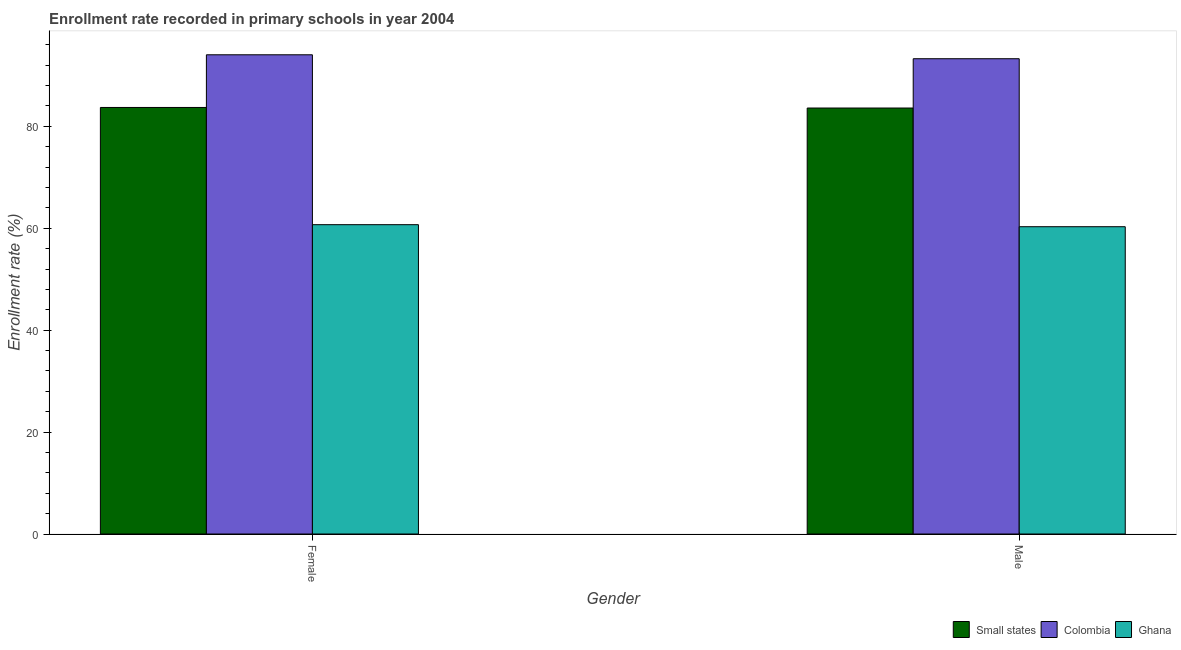How many bars are there on the 2nd tick from the left?
Keep it short and to the point. 3. What is the label of the 1st group of bars from the left?
Your response must be concise. Female. What is the enrollment rate of male students in Ghana?
Provide a short and direct response. 60.31. Across all countries, what is the maximum enrollment rate of female students?
Give a very brief answer. 94.05. Across all countries, what is the minimum enrollment rate of female students?
Your answer should be very brief. 60.71. In which country was the enrollment rate of female students maximum?
Your answer should be compact. Colombia. What is the total enrollment rate of male students in the graph?
Provide a succinct answer. 237.18. What is the difference between the enrollment rate of male students in Ghana and that in Colombia?
Offer a terse response. -32.97. What is the difference between the enrollment rate of female students in Small states and the enrollment rate of male students in Colombia?
Offer a terse response. -9.56. What is the average enrollment rate of male students per country?
Offer a very short reply. 79.06. What is the difference between the enrollment rate of female students and enrollment rate of male students in Colombia?
Offer a terse response. 0.77. In how many countries, is the enrollment rate of male students greater than 64 %?
Offer a very short reply. 2. What is the ratio of the enrollment rate of female students in Small states to that in Colombia?
Offer a terse response. 0.89. Is the enrollment rate of male students in Small states less than that in Colombia?
Make the answer very short. Yes. In how many countries, is the enrollment rate of female students greater than the average enrollment rate of female students taken over all countries?
Your answer should be compact. 2. What does the 1st bar from the left in Female represents?
Keep it short and to the point. Small states. How many bars are there?
Ensure brevity in your answer.  6. How many countries are there in the graph?
Give a very brief answer. 3. What is the difference between two consecutive major ticks on the Y-axis?
Your answer should be compact. 20. Does the graph contain grids?
Keep it short and to the point. No. How are the legend labels stacked?
Your answer should be compact. Horizontal. What is the title of the graph?
Offer a very short reply. Enrollment rate recorded in primary schools in year 2004. What is the label or title of the X-axis?
Provide a short and direct response. Gender. What is the label or title of the Y-axis?
Give a very brief answer. Enrollment rate (%). What is the Enrollment rate (%) of Small states in Female?
Your answer should be very brief. 83.71. What is the Enrollment rate (%) in Colombia in Female?
Your answer should be very brief. 94.05. What is the Enrollment rate (%) in Ghana in Female?
Give a very brief answer. 60.71. What is the Enrollment rate (%) in Small states in Male?
Your response must be concise. 83.6. What is the Enrollment rate (%) in Colombia in Male?
Offer a very short reply. 93.27. What is the Enrollment rate (%) of Ghana in Male?
Your answer should be very brief. 60.31. Across all Gender, what is the maximum Enrollment rate (%) in Small states?
Your response must be concise. 83.71. Across all Gender, what is the maximum Enrollment rate (%) in Colombia?
Your answer should be very brief. 94.05. Across all Gender, what is the maximum Enrollment rate (%) in Ghana?
Make the answer very short. 60.71. Across all Gender, what is the minimum Enrollment rate (%) of Small states?
Offer a terse response. 83.6. Across all Gender, what is the minimum Enrollment rate (%) of Colombia?
Keep it short and to the point. 93.27. Across all Gender, what is the minimum Enrollment rate (%) of Ghana?
Make the answer very short. 60.31. What is the total Enrollment rate (%) in Small states in the graph?
Your answer should be compact. 167.31. What is the total Enrollment rate (%) in Colombia in the graph?
Provide a succinct answer. 187.32. What is the total Enrollment rate (%) in Ghana in the graph?
Your answer should be compact. 121.01. What is the difference between the Enrollment rate (%) of Small states in Female and that in Male?
Ensure brevity in your answer.  0.11. What is the difference between the Enrollment rate (%) in Colombia in Female and that in Male?
Your answer should be very brief. 0.77. What is the difference between the Enrollment rate (%) in Ghana in Female and that in Male?
Make the answer very short. 0.4. What is the difference between the Enrollment rate (%) of Small states in Female and the Enrollment rate (%) of Colombia in Male?
Your answer should be very brief. -9.56. What is the difference between the Enrollment rate (%) of Small states in Female and the Enrollment rate (%) of Ghana in Male?
Offer a very short reply. 23.4. What is the difference between the Enrollment rate (%) in Colombia in Female and the Enrollment rate (%) in Ghana in Male?
Your response must be concise. 33.74. What is the average Enrollment rate (%) of Small states per Gender?
Offer a very short reply. 83.65. What is the average Enrollment rate (%) in Colombia per Gender?
Ensure brevity in your answer.  93.66. What is the average Enrollment rate (%) of Ghana per Gender?
Offer a very short reply. 60.51. What is the difference between the Enrollment rate (%) in Small states and Enrollment rate (%) in Colombia in Female?
Give a very brief answer. -10.34. What is the difference between the Enrollment rate (%) of Small states and Enrollment rate (%) of Ghana in Female?
Give a very brief answer. 23. What is the difference between the Enrollment rate (%) in Colombia and Enrollment rate (%) in Ghana in Female?
Ensure brevity in your answer.  33.34. What is the difference between the Enrollment rate (%) of Small states and Enrollment rate (%) of Colombia in Male?
Ensure brevity in your answer.  -9.68. What is the difference between the Enrollment rate (%) of Small states and Enrollment rate (%) of Ghana in Male?
Your response must be concise. 23.29. What is the difference between the Enrollment rate (%) of Colombia and Enrollment rate (%) of Ghana in Male?
Your answer should be very brief. 32.97. What is the ratio of the Enrollment rate (%) of Colombia in Female to that in Male?
Your answer should be compact. 1.01. What is the ratio of the Enrollment rate (%) of Ghana in Female to that in Male?
Your answer should be compact. 1.01. What is the difference between the highest and the second highest Enrollment rate (%) of Small states?
Give a very brief answer. 0.11. What is the difference between the highest and the second highest Enrollment rate (%) in Colombia?
Offer a terse response. 0.77. What is the difference between the highest and the second highest Enrollment rate (%) in Ghana?
Your response must be concise. 0.4. What is the difference between the highest and the lowest Enrollment rate (%) in Small states?
Your answer should be compact. 0.11. What is the difference between the highest and the lowest Enrollment rate (%) in Colombia?
Give a very brief answer. 0.77. What is the difference between the highest and the lowest Enrollment rate (%) of Ghana?
Give a very brief answer. 0.4. 